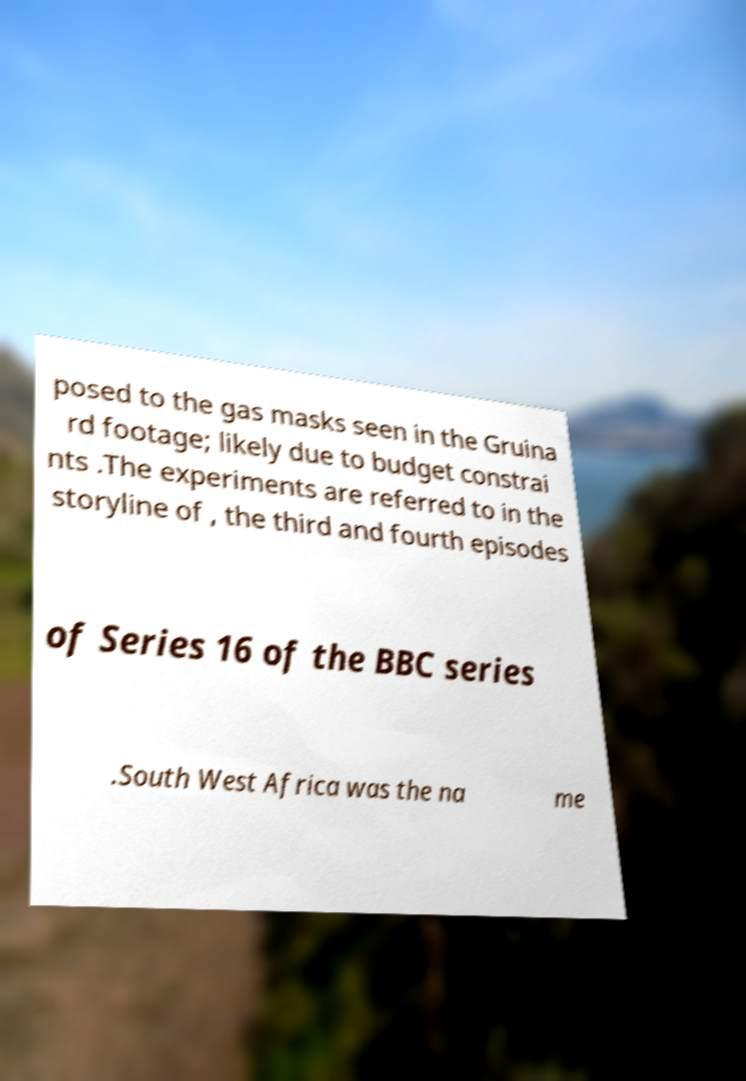Could you extract and type out the text from this image? posed to the gas masks seen in the Gruina rd footage; likely due to budget constrai nts .The experiments are referred to in the storyline of , the third and fourth episodes of Series 16 of the BBC series .South West Africa was the na me 